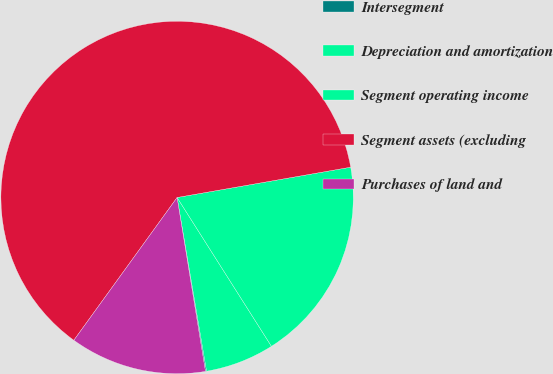Convert chart. <chart><loc_0><loc_0><loc_500><loc_500><pie_chart><fcel>Intersegment<fcel>Depreciation and amortization<fcel>Segment operating income<fcel>Segment assets (excluding<fcel>Purchases of land and<nl><fcel>0.1%<fcel>6.32%<fcel>18.76%<fcel>62.29%<fcel>12.54%<nl></chart> 